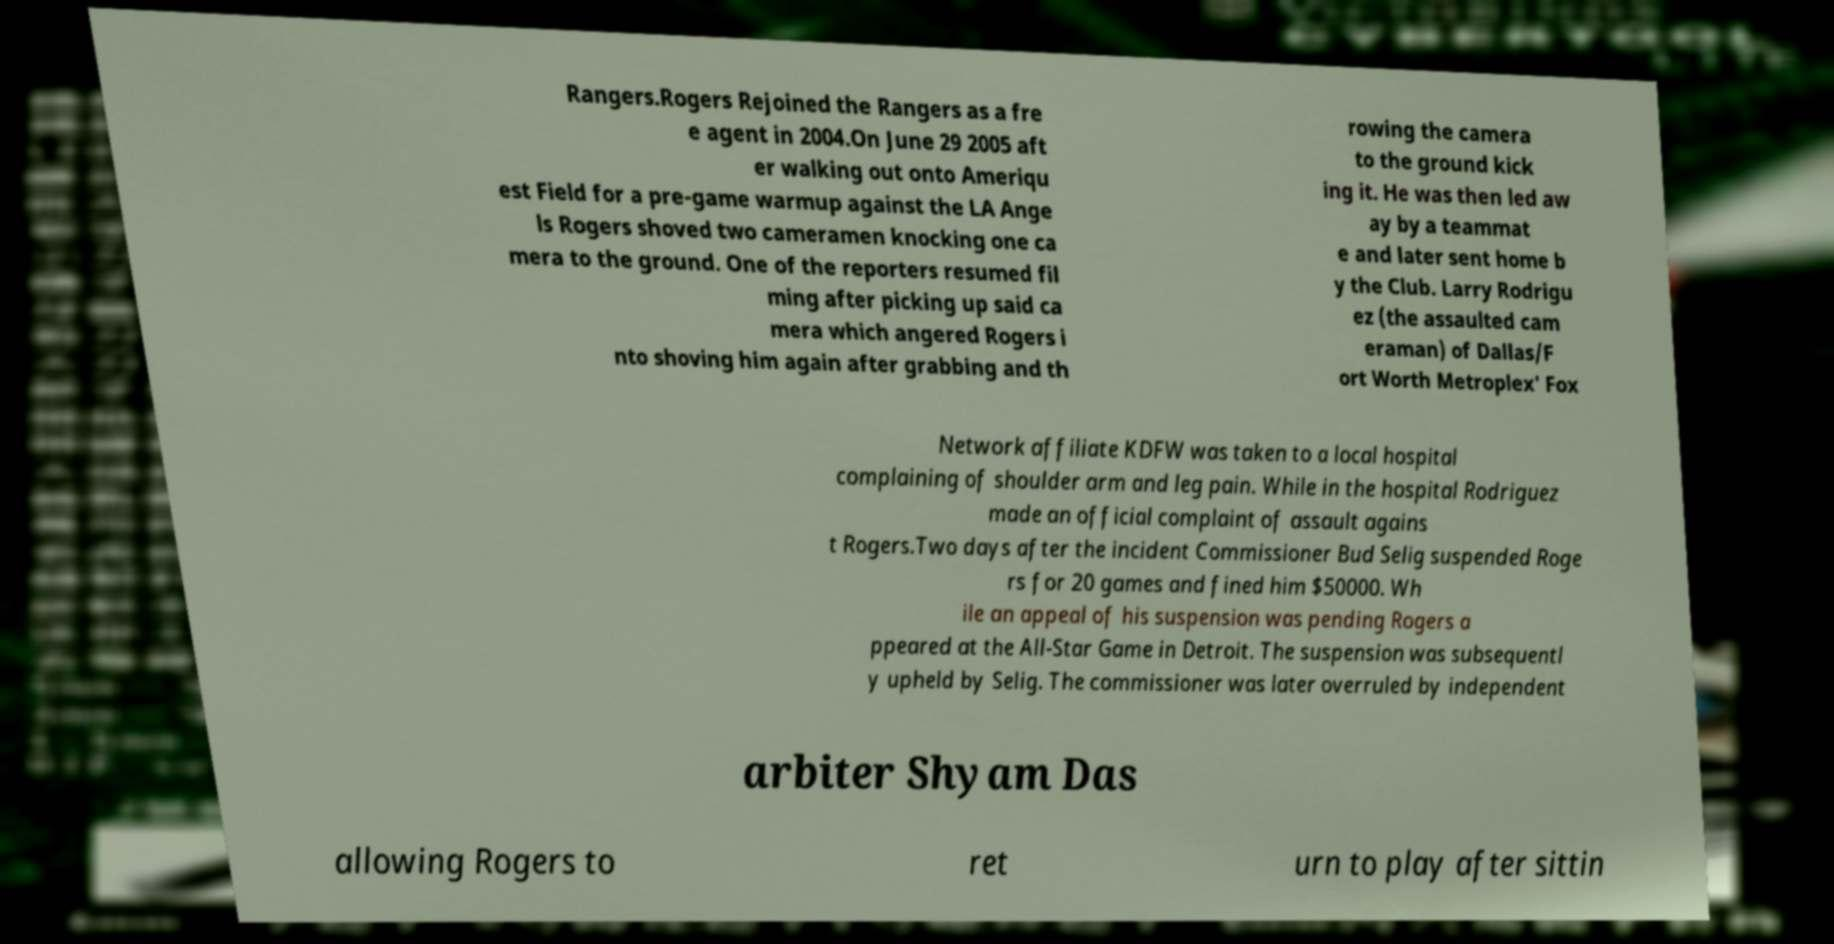Can you accurately transcribe the text from the provided image for me? Rangers.Rogers Rejoined the Rangers as a fre e agent in 2004.On June 29 2005 aft er walking out onto Ameriqu est Field for a pre-game warmup against the LA Ange ls Rogers shoved two cameramen knocking one ca mera to the ground. One of the reporters resumed fil ming after picking up said ca mera which angered Rogers i nto shoving him again after grabbing and th rowing the camera to the ground kick ing it. He was then led aw ay by a teammat e and later sent home b y the Club. Larry Rodrigu ez (the assaulted cam eraman) of Dallas/F ort Worth Metroplex' Fox Network affiliate KDFW was taken to a local hospital complaining of shoulder arm and leg pain. While in the hospital Rodriguez made an official complaint of assault agains t Rogers.Two days after the incident Commissioner Bud Selig suspended Roge rs for 20 games and fined him $50000. Wh ile an appeal of his suspension was pending Rogers a ppeared at the All-Star Game in Detroit. The suspension was subsequentl y upheld by Selig. The commissioner was later overruled by independent arbiter Shyam Das allowing Rogers to ret urn to play after sittin 